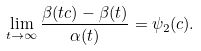Convert formula to latex. <formula><loc_0><loc_0><loc_500><loc_500>\lim _ { t \to \infty } \frac { \beta ( t c ) - \beta ( t ) } { \alpha ( t ) } = \psi _ { 2 } ( c ) .</formula> 